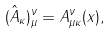Convert formula to latex. <formula><loc_0><loc_0><loc_500><loc_500>( \hat { A } _ { \kappa } ) _ { \mu } ^ { \nu } = A _ { \mu \kappa } ^ { \nu } ( x ) ,</formula> 